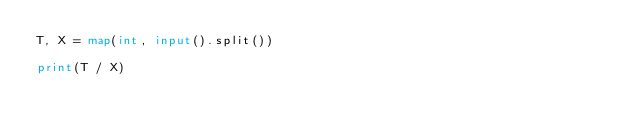Convert code to text. <code><loc_0><loc_0><loc_500><loc_500><_Python_>T, X = map(int, input().split())

print(T / X)</code> 